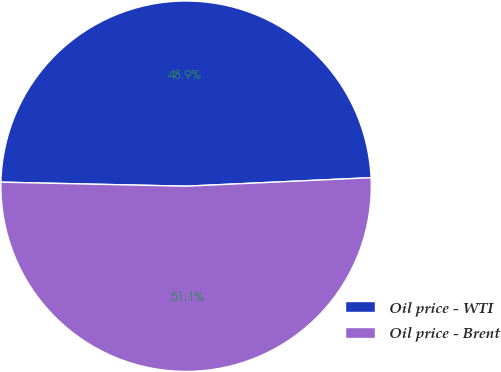Convert chart to OTSL. <chart><loc_0><loc_0><loc_500><loc_500><pie_chart><fcel>Oil price - WTI<fcel>Oil price - Brent<nl><fcel>48.92%<fcel>51.08%<nl></chart> 